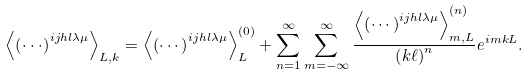<formula> <loc_0><loc_0><loc_500><loc_500>\left \langle \left ( \cdot \cdot \cdot \right ) ^ { i j h l \lambda \mu } \right \rangle _ { L , k } = \left \langle \left ( \cdots \right ) ^ { i j h l \lambda \mu } \right \rangle _ { L } ^ { \left ( 0 \right ) } + \sum _ { n = 1 } ^ { \infty } \sum _ { m = - \infty } ^ { \infty } \frac { \left \langle \left ( \cdots \right ) ^ { i j h l \lambda \mu } \right \rangle _ { m , L } ^ { \left ( n \right ) } } { \left ( k \ell \right ) ^ { n } } e ^ { i m k L } .</formula> 